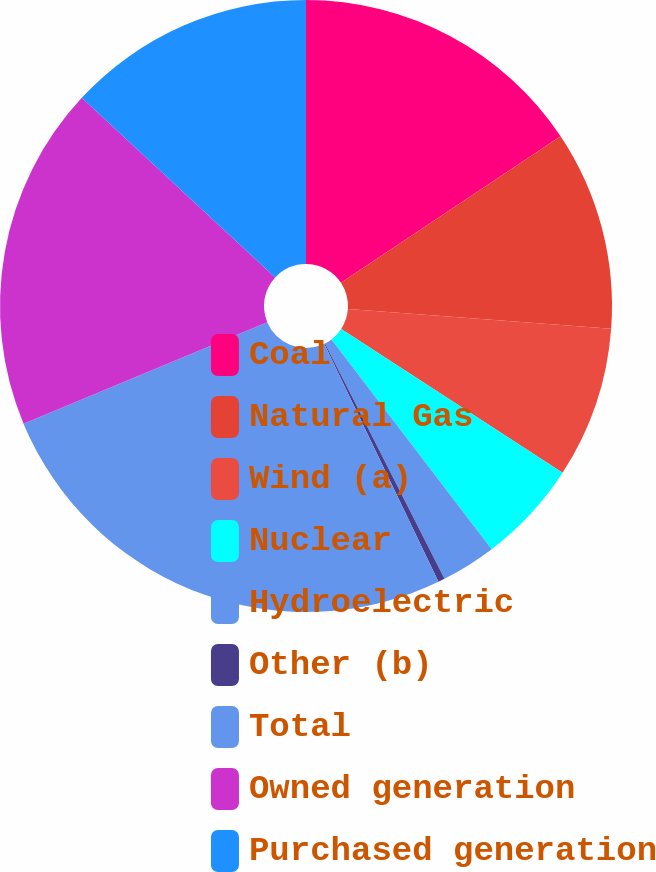Convert chart. <chart><loc_0><loc_0><loc_500><loc_500><pie_chart><fcel>Coal<fcel>Natural Gas<fcel>Wind (a)<fcel>Nuclear<fcel>Hydroelectric<fcel>Other (b)<fcel>Total<fcel>Owned generation<fcel>Purchased generation<nl><fcel>15.64%<fcel>10.54%<fcel>7.99%<fcel>5.45%<fcel>2.9%<fcel>0.35%<fcel>25.84%<fcel>18.19%<fcel>13.09%<nl></chart> 